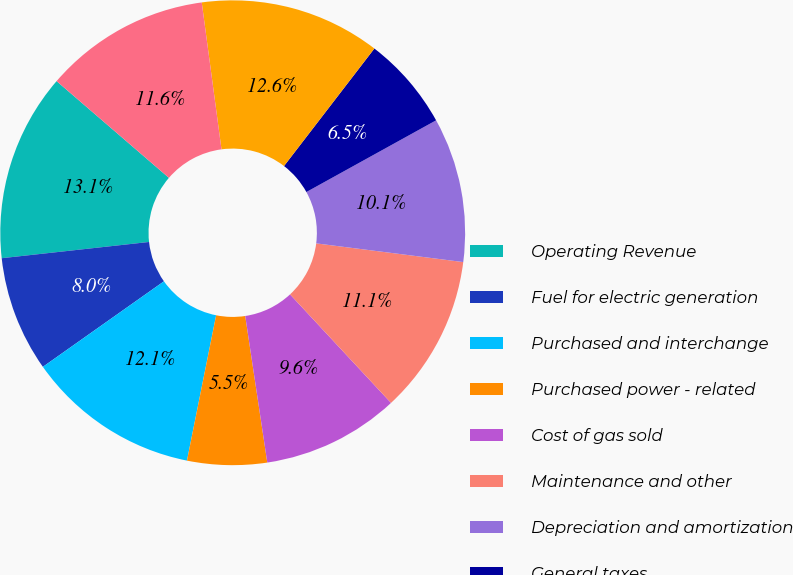Convert chart. <chart><loc_0><loc_0><loc_500><loc_500><pie_chart><fcel>Operating Revenue<fcel>Fuel for electric generation<fcel>Purchased and interchange<fcel>Purchased power - related<fcel>Cost of gas sold<fcel>Maintenance and other<fcel>Depreciation and amortization<fcel>General taxes<fcel>Total operating expenses<fcel>Operating Income<nl><fcel>13.06%<fcel>8.04%<fcel>12.06%<fcel>5.53%<fcel>9.55%<fcel>11.06%<fcel>10.05%<fcel>6.53%<fcel>12.56%<fcel>11.56%<nl></chart> 